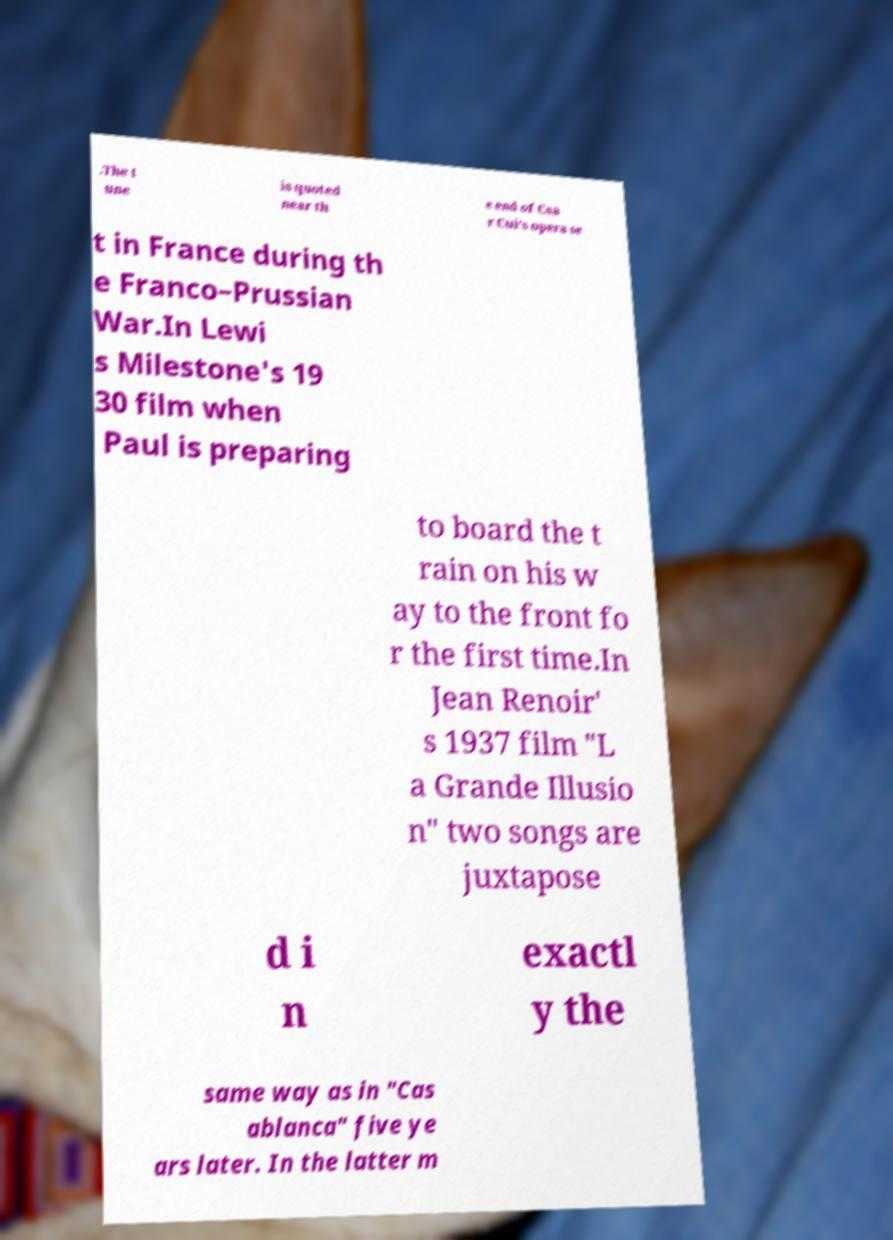Can you accurately transcribe the text from the provided image for me? .The t une is quoted near th e end of Csa r Cui's opera se t in France during th e Franco–Prussian War.In Lewi s Milestone's 19 30 film when Paul is preparing to board the t rain on his w ay to the front fo r the first time.In Jean Renoir' s 1937 film "L a Grande Illusio n" two songs are juxtapose d i n exactl y the same way as in "Cas ablanca" five ye ars later. In the latter m 